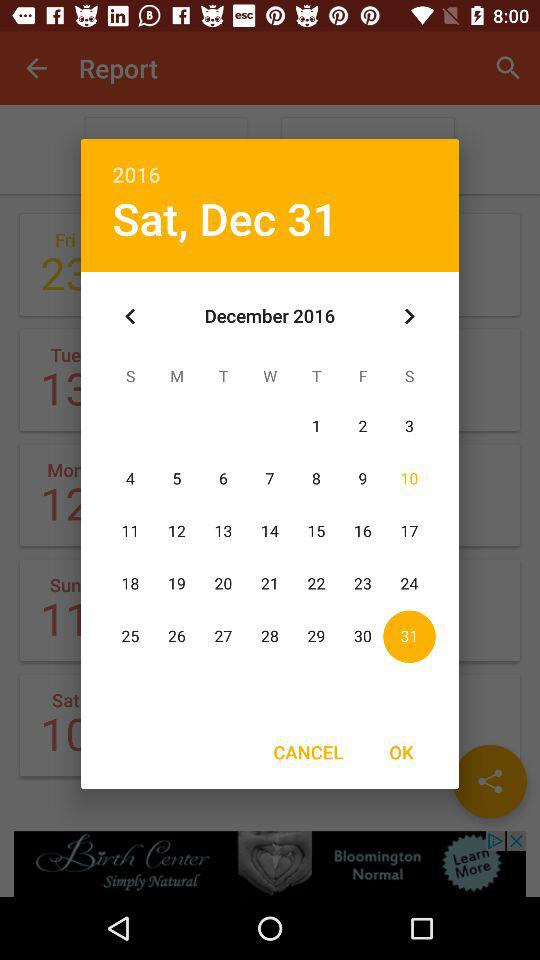What day was December 31st, 2016? The day was Saturday. 